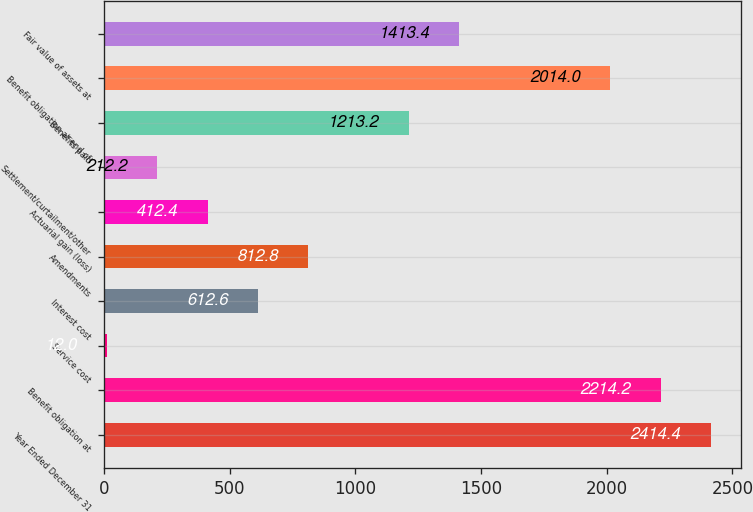Convert chart. <chart><loc_0><loc_0><loc_500><loc_500><bar_chart><fcel>Year Ended December 31<fcel>Benefit obligation at<fcel>Service cost<fcel>Interest cost<fcel>Amendments<fcel>Actuarial gain (loss)<fcel>Settlement/curtailment/other<fcel>Benefits paid<fcel>Benefit obligation at end of<fcel>Fair value of assets at<nl><fcel>2414.4<fcel>2214.2<fcel>12<fcel>612.6<fcel>812.8<fcel>412.4<fcel>212.2<fcel>1213.2<fcel>2014<fcel>1413.4<nl></chart> 